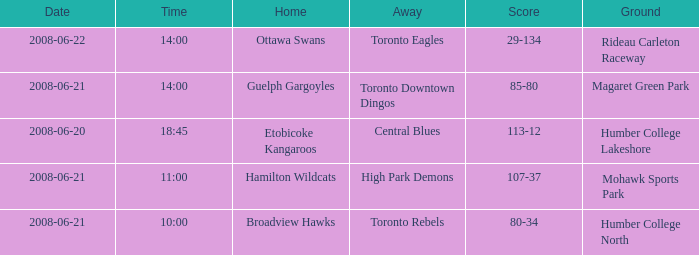Parse the table in full. {'header': ['Date', 'Time', 'Home', 'Away', 'Score', 'Ground'], 'rows': [['2008-06-22', '14:00', 'Ottawa Swans', 'Toronto Eagles', '29-134', 'Rideau Carleton Raceway'], ['2008-06-21', '14:00', 'Guelph Gargoyles', 'Toronto Downtown Dingos', '85-80', 'Magaret Green Park'], ['2008-06-20', '18:45', 'Etobicoke Kangaroos', 'Central Blues', '113-12', 'Humber College Lakeshore'], ['2008-06-21', '11:00', 'Hamilton Wildcats', 'High Park Demons', '107-37', 'Mohawk Sports Park'], ['2008-06-21', '10:00', 'Broadview Hawks', 'Toronto Rebels', '80-34', 'Humber College North']]} When the score ranges from 80 to 34, what is the time? 10:00. 